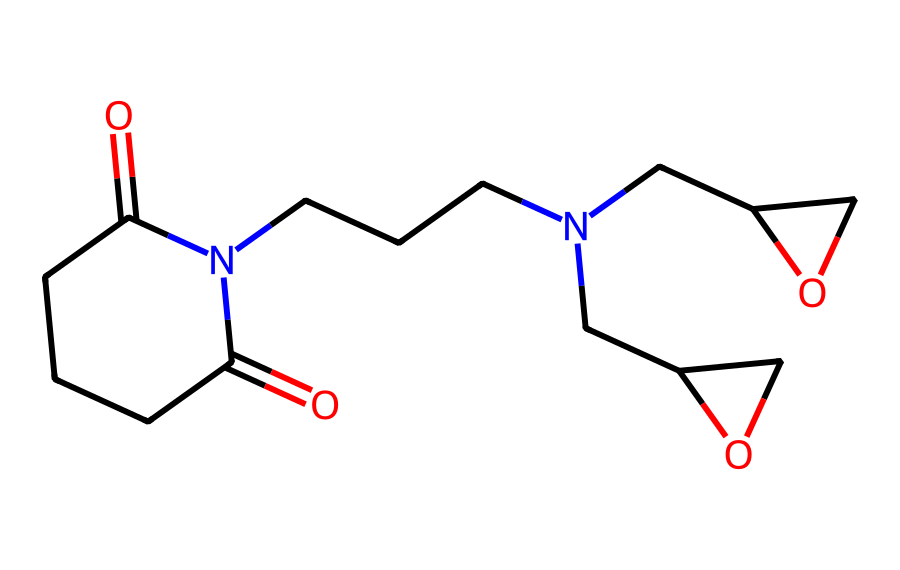What functional groups are present in this chemical structure? By examining the chemical structure, we can identify multiple functional groups such as carbonyl (C=O) groups, an amide (C(=O)N) due to the nitrogen connected to a carbonyl, and potentially ether groups due to the oxygen atoms connected to carbon chains.
Answer: carbonyl, amide, ether How many nitrogen atoms are in this chemical? Counting the nitrogen atoms in the SMILES representation, there are two occurrences of nitrogen represented by 'N'.
Answer: 2 What is the main type of bonding observed in this imide compound? The presence of carbonyl groups and nitrogen indicates the formation of covalent bonds, specifically involving double bonds (in carbonyls) and single bonds with nitrogen. The nitrogen functionalities also imply amide bonds.
Answer: covalent What type of polymerization process can this imide participate in? Imides, particularly in epoxy hardeners, can undergo cross-linking reactions attributable to their reactive amide groups, making them suitable for thermosetting materials.
Answer: cross-linking What is the basic structure characteristic of imides present in this chemical? The basic structure characteristic of imides is the presence of a cyclic structure with both carbonyl and nitrogen groups sharing a set of substituents, which distinguishes them from other amides.
Answer: cyclic structure with carbonyl and nitrogen 